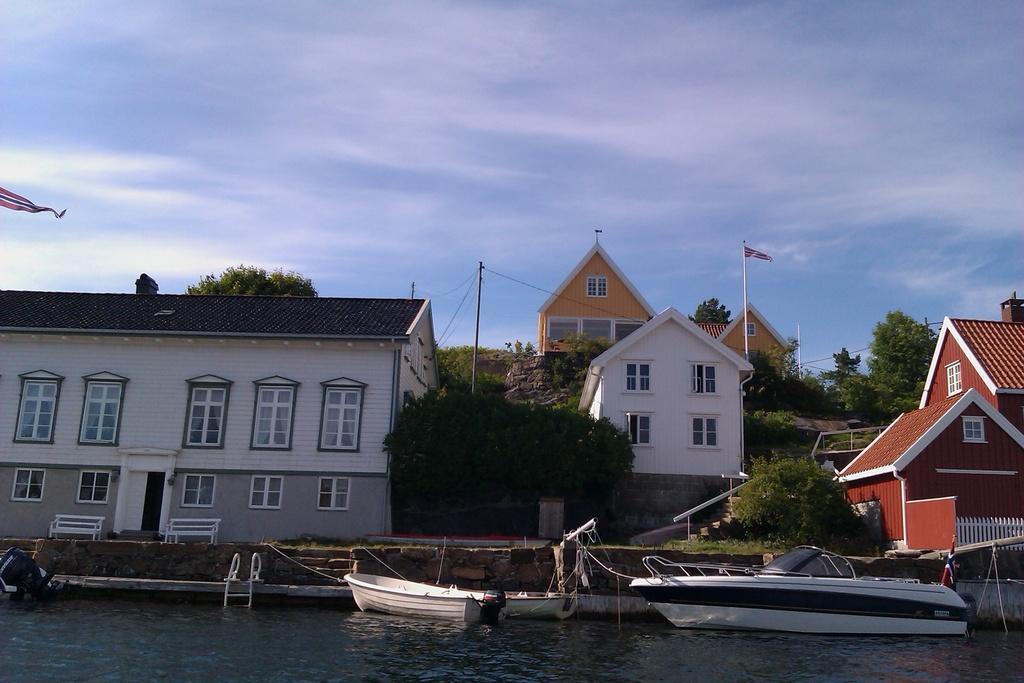Describe this image in one or two sentences. In this image I can see water in the front and on it I can see few boats. On the right side of the image I can see a flag on the boat. In the background I can see few buildings, number of trees, few poles, two flags, few wires, clouds and the sky. On the left side of the image I can see two white colour benches. 